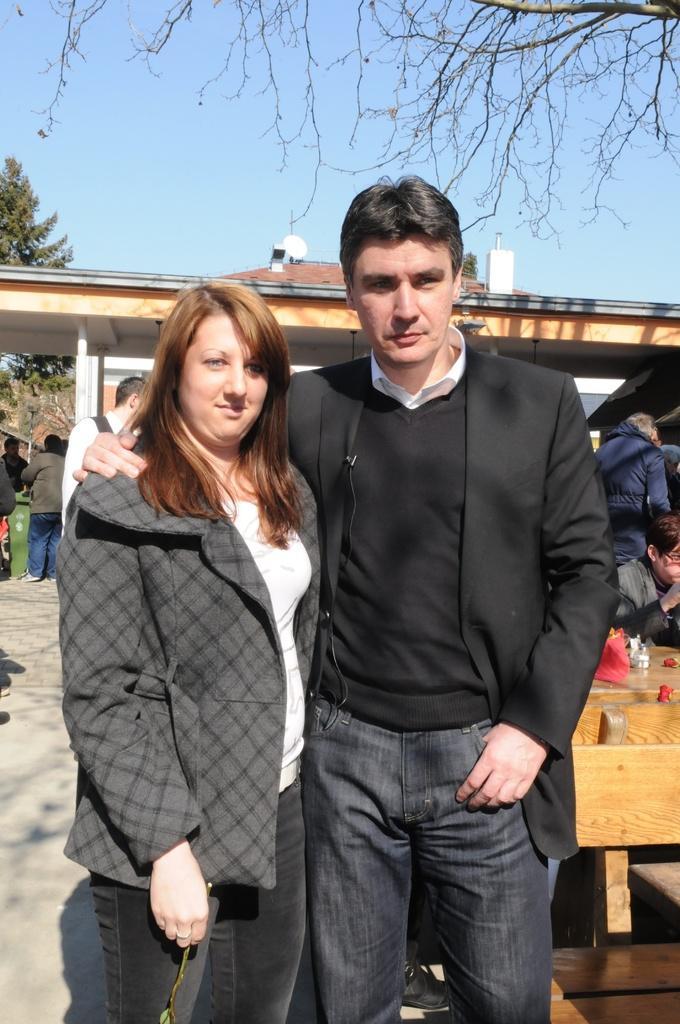Describe this image in one or two sentences. In this image there are two persons standing, beside them there are few wooden benches, in front of the benches there are a few people standing. In the background there is a building, trees and a sky. 